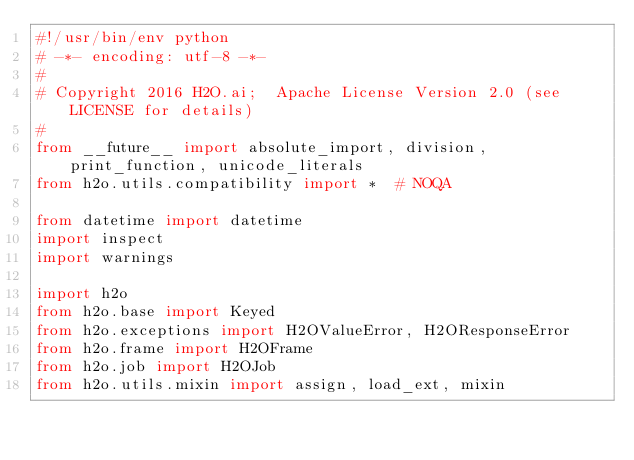Convert code to text. <code><loc_0><loc_0><loc_500><loc_500><_Python_>#!/usr/bin/env python
# -*- encoding: utf-8 -*-
#
# Copyright 2016 H2O.ai;  Apache License Version 2.0 (see LICENSE for details)
#
from __future__ import absolute_import, division, print_function, unicode_literals
from h2o.utils.compatibility import *  # NOQA

from datetime import datetime
import inspect
import warnings

import h2o
from h2o.base import Keyed
from h2o.exceptions import H2OValueError, H2OResponseError
from h2o.frame import H2OFrame
from h2o.job import H2OJob
from h2o.utils.mixin import assign, load_ext, mixin</code> 